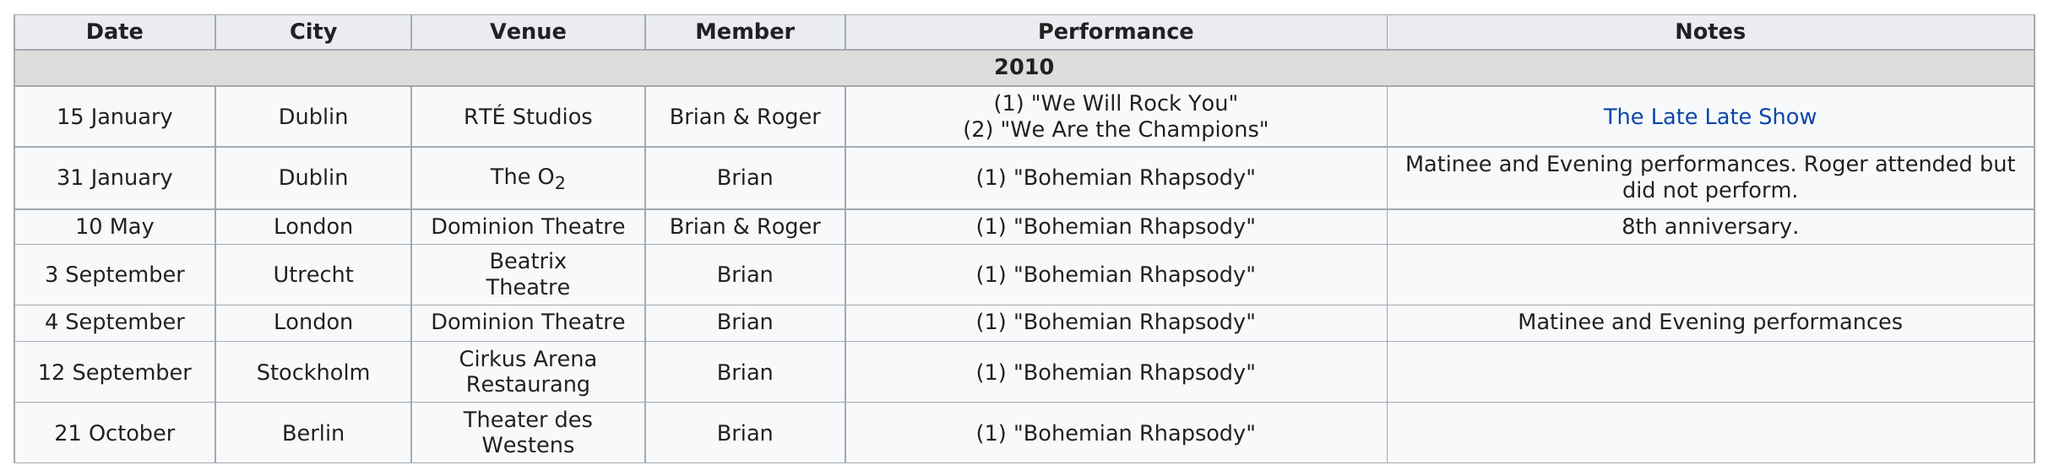Identify some key points in this picture. The last tour date of 2010 was on October 21st. London came before Utrecht, Stockholm, and other cities. Brian performed in Theater des Westens for the last time. The first tour date of 2010 was on January 15th. The venue known as "Domination Theater" was performed a total of two times. 